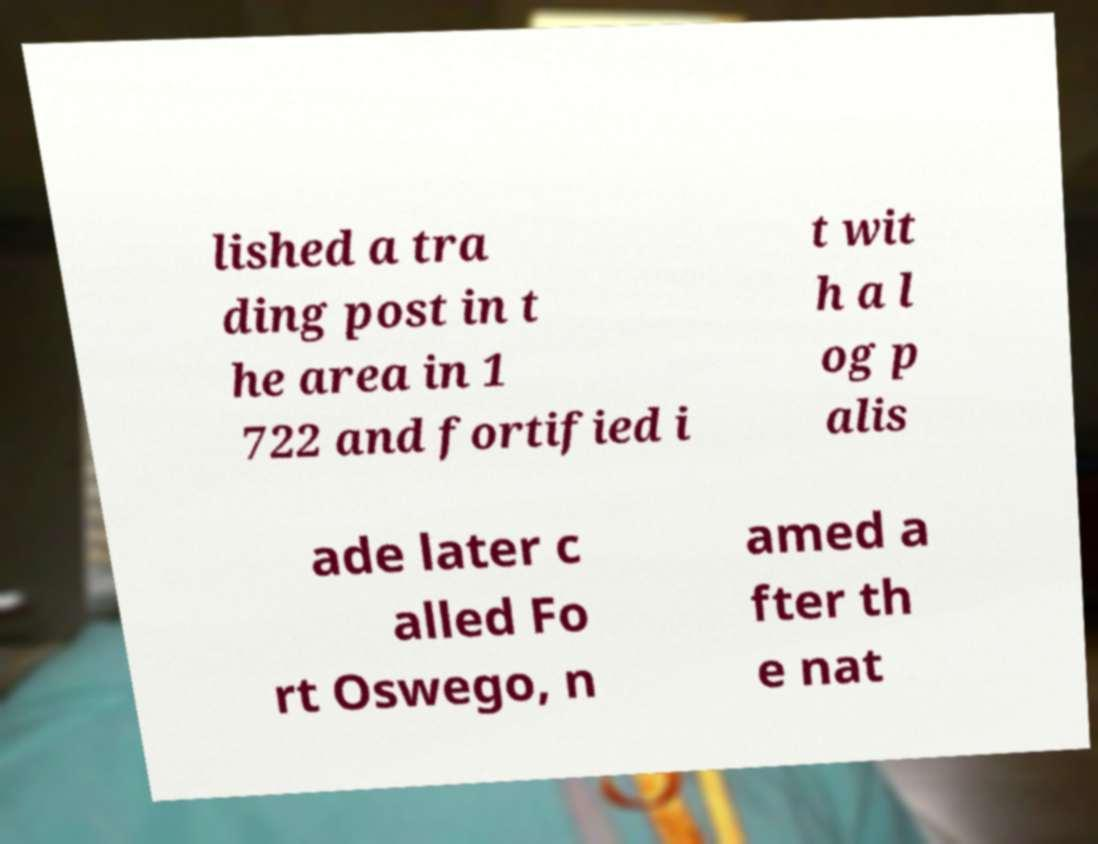Please identify and transcribe the text found in this image. lished a tra ding post in t he area in 1 722 and fortified i t wit h a l og p alis ade later c alled Fo rt Oswego, n amed a fter th e nat 